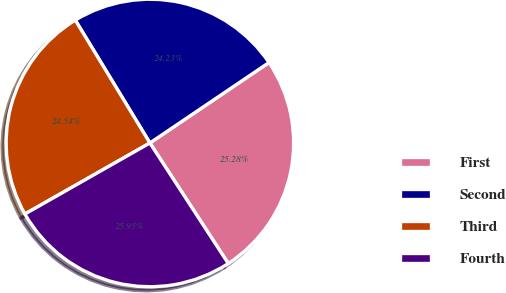Convert chart. <chart><loc_0><loc_0><loc_500><loc_500><pie_chart><fcel>First<fcel>Second<fcel>Third<fcel>Fourth<nl><fcel>25.28%<fcel>24.23%<fcel>24.54%<fcel>25.95%<nl></chart> 